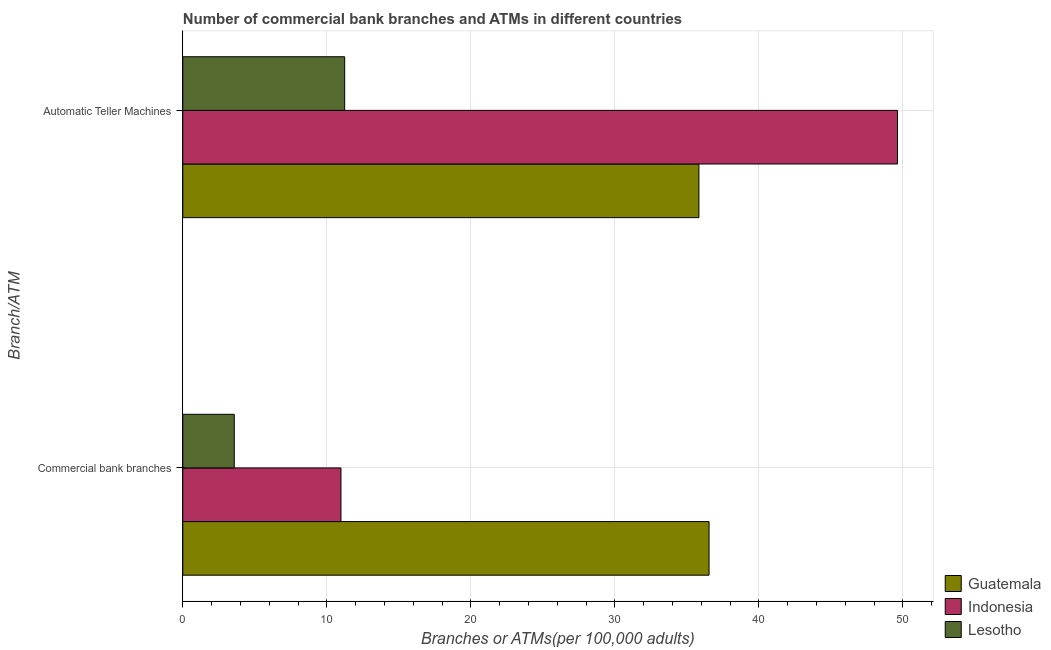Are the number of bars on each tick of the Y-axis equal?
Your response must be concise. Yes. How many bars are there on the 1st tick from the bottom?
Ensure brevity in your answer.  3. What is the label of the 1st group of bars from the top?
Your answer should be very brief. Automatic Teller Machines. What is the number of atms in Lesotho?
Provide a short and direct response. 11.24. Across all countries, what is the maximum number of commercal bank branches?
Give a very brief answer. 36.55. Across all countries, what is the minimum number of commercal bank branches?
Your answer should be very brief. 3.57. In which country was the number of commercal bank branches minimum?
Your answer should be compact. Lesotho. What is the total number of atms in the graph?
Give a very brief answer. 96.71. What is the difference between the number of commercal bank branches in Indonesia and that in Lesotho?
Provide a succinct answer. 7.41. What is the difference between the number of atms in Lesotho and the number of commercal bank branches in Indonesia?
Your response must be concise. 0.26. What is the average number of commercal bank branches per country?
Provide a short and direct response. 17.03. What is the difference between the number of atms and number of commercal bank branches in Guatemala?
Offer a very short reply. -0.7. What is the ratio of the number of atms in Indonesia to that in Guatemala?
Offer a very short reply. 1.38. Is the number of atms in Lesotho less than that in Indonesia?
Offer a very short reply. Yes. In how many countries, is the number of atms greater than the average number of atms taken over all countries?
Offer a terse response. 2. What does the 3rd bar from the top in Commercial bank branches represents?
Make the answer very short. Guatemala. What does the 1st bar from the bottom in Automatic Teller Machines represents?
Make the answer very short. Guatemala. Are all the bars in the graph horizontal?
Provide a succinct answer. Yes. What is the difference between two consecutive major ticks on the X-axis?
Your answer should be very brief. 10. Does the graph contain grids?
Your answer should be very brief. Yes. How many legend labels are there?
Offer a terse response. 3. How are the legend labels stacked?
Your response must be concise. Vertical. What is the title of the graph?
Offer a very short reply. Number of commercial bank branches and ATMs in different countries. What is the label or title of the X-axis?
Offer a very short reply. Branches or ATMs(per 100,0 adults). What is the label or title of the Y-axis?
Your answer should be very brief. Branch/ATM. What is the Branches or ATMs(per 100,000 adults) in Guatemala in Commercial bank branches?
Offer a terse response. 36.55. What is the Branches or ATMs(per 100,000 adults) in Indonesia in Commercial bank branches?
Your answer should be compact. 10.98. What is the Branches or ATMs(per 100,000 adults) in Lesotho in Commercial bank branches?
Provide a succinct answer. 3.57. What is the Branches or ATMs(per 100,000 adults) of Guatemala in Automatic Teller Machines?
Offer a very short reply. 35.84. What is the Branches or ATMs(per 100,000 adults) in Indonesia in Automatic Teller Machines?
Your response must be concise. 49.63. What is the Branches or ATMs(per 100,000 adults) of Lesotho in Automatic Teller Machines?
Provide a short and direct response. 11.24. Across all Branch/ATM, what is the maximum Branches or ATMs(per 100,000 adults) of Guatemala?
Ensure brevity in your answer.  36.55. Across all Branch/ATM, what is the maximum Branches or ATMs(per 100,000 adults) in Indonesia?
Provide a succinct answer. 49.63. Across all Branch/ATM, what is the maximum Branches or ATMs(per 100,000 adults) of Lesotho?
Make the answer very short. 11.24. Across all Branch/ATM, what is the minimum Branches or ATMs(per 100,000 adults) in Guatemala?
Provide a short and direct response. 35.84. Across all Branch/ATM, what is the minimum Branches or ATMs(per 100,000 adults) of Indonesia?
Your answer should be compact. 10.98. Across all Branch/ATM, what is the minimum Branches or ATMs(per 100,000 adults) in Lesotho?
Your answer should be compact. 3.57. What is the total Branches or ATMs(per 100,000 adults) of Guatemala in the graph?
Offer a terse response. 72.39. What is the total Branches or ATMs(per 100,000 adults) of Indonesia in the graph?
Your answer should be compact. 60.61. What is the total Branches or ATMs(per 100,000 adults) in Lesotho in the graph?
Make the answer very short. 14.81. What is the difference between the Branches or ATMs(per 100,000 adults) of Guatemala in Commercial bank branches and that in Automatic Teller Machines?
Your answer should be compact. 0.7. What is the difference between the Branches or ATMs(per 100,000 adults) of Indonesia in Commercial bank branches and that in Automatic Teller Machines?
Keep it short and to the point. -38.64. What is the difference between the Branches or ATMs(per 100,000 adults) in Lesotho in Commercial bank branches and that in Automatic Teller Machines?
Provide a short and direct response. -7.67. What is the difference between the Branches or ATMs(per 100,000 adults) in Guatemala in Commercial bank branches and the Branches or ATMs(per 100,000 adults) in Indonesia in Automatic Teller Machines?
Keep it short and to the point. -13.08. What is the difference between the Branches or ATMs(per 100,000 adults) of Guatemala in Commercial bank branches and the Branches or ATMs(per 100,000 adults) of Lesotho in Automatic Teller Machines?
Provide a succinct answer. 25.3. What is the difference between the Branches or ATMs(per 100,000 adults) of Indonesia in Commercial bank branches and the Branches or ATMs(per 100,000 adults) of Lesotho in Automatic Teller Machines?
Make the answer very short. -0.26. What is the average Branches or ATMs(per 100,000 adults) in Guatemala per Branch/ATM?
Offer a very short reply. 36.19. What is the average Branches or ATMs(per 100,000 adults) of Indonesia per Branch/ATM?
Offer a very short reply. 30.31. What is the average Branches or ATMs(per 100,000 adults) of Lesotho per Branch/ATM?
Your answer should be compact. 7.41. What is the difference between the Branches or ATMs(per 100,000 adults) in Guatemala and Branches or ATMs(per 100,000 adults) in Indonesia in Commercial bank branches?
Provide a short and direct response. 25.56. What is the difference between the Branches or ATMs(per 100,000 adults) in Guatemala and Branches or ATMs(per 100,000 adults) in Lesotho in Commercial bank branches?
Make the answer very short. 32.97. What is the difference between the Branches or ATMs(per 100,000 adults) in Indonesia and Branches or ATMs(per 100,000 adults) in Lesotho in Commercial bank branches?
Your answer should be compact. 7.41. What is the difference between the Branches or ATMs(per 100,000 adults) in Guatemala and Branches or ATMs(per 100,000 adults) in Indonesia in Automatic Teller Machines?
Make the answer very short. -13.79. What is the difference between the Branches or ATMs(per 100,000 adults) of Guatemala and Branches or ATMs(per 100,000 adults) of Lesotho in Automatic Teller Machines?
Your answer should be very brief. 24.6. What is the difference between the Branches or ATMs(per 100,000 adults) in Indonesia and Branches or ATMs(per 100,000 adults) in Lesotho in Automatic Teller Machines?
Your answer should be compact. 38.39. What is the ratio of the Branches or ATMs(per 100,000 adults) of Guatemala in Commercial bank branches to that in Automatic Teller Machines?
Keep it short and to the point. 1.02. What is the ratio of the Branches or ATMs(per 100,000 adults) of Indonesia in Commercial bank branches to that in Automatic Teller Machines?
Your response must be concise. 0.22. What is the ratio of the Branches or ATMs(per 100,000 adults) in Lesotho in Commercial bank branches to that in Automatic Teller Machines?
Offer a terse response. 0.32. What is the difference between the highest and the second highest Branches or ATMs(per 100,000 adults) in Guatemala?
Provide a short and direct response. 0.7. What is the difference between the highest and the second highest Branches or ATMs(per 100,000 adults) in Indonesia?
Your answer should be compact. 38.64. What is the difference between the highest and the second highest Branches or ATMs(per 100,000 adults) of Lesotho?
Make the answer very short. 7.67. What is the difference between the highest and the lowest Branches or ATMs(per 100,000 adults) in Guatemala?
Provide a succinct answer. 0.7. What is the difference between the highest and the lowest Branches or ATMs(per 100,000 adults) in Indonesia?
Offer a terse response. 38.64. What is the difference between the highest and the lowest Branches or ATMs(per 100,000 adults) of Lesotho?
Offer a terse response. 7.67. 